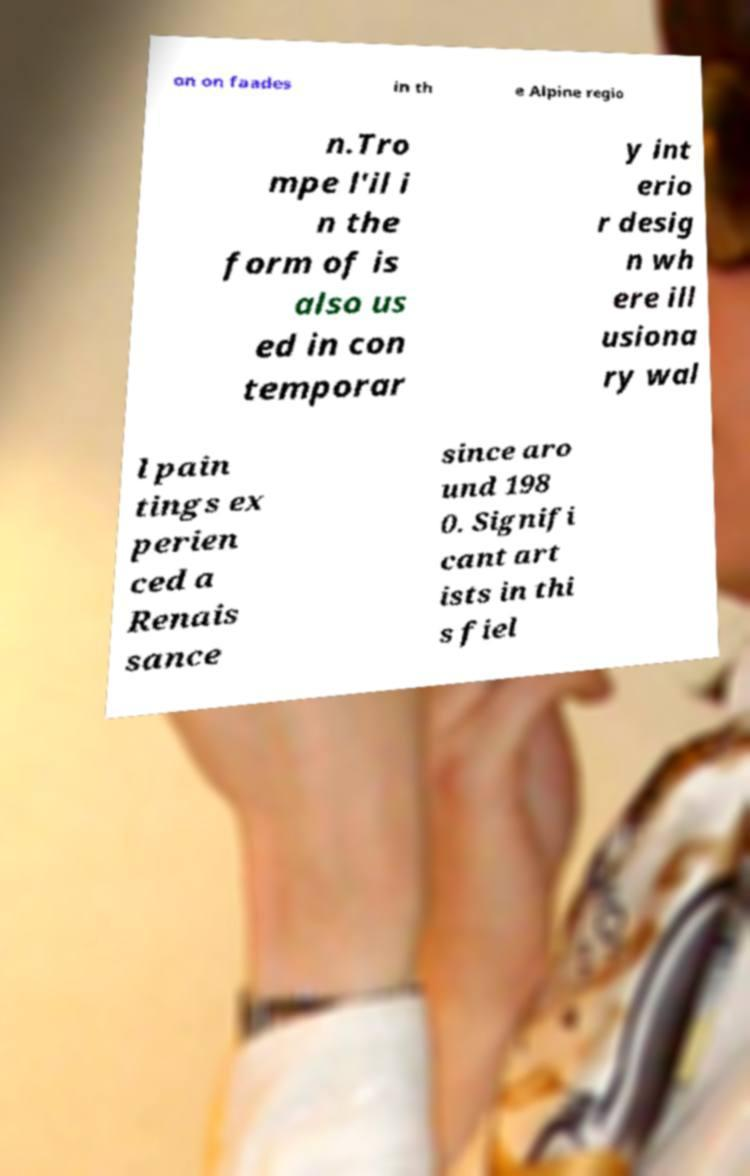Could you extract and type out the text from this image? on on faades in th e Alpine regio n.Tro mpe l'il i n the form of is also us ed in con temporar y int erio r desig n wh ere ill usiona ry wal l pain tings ex perien ced a Renais sance since aro und 198 0. Signifi cant art ists in thi s fiel 